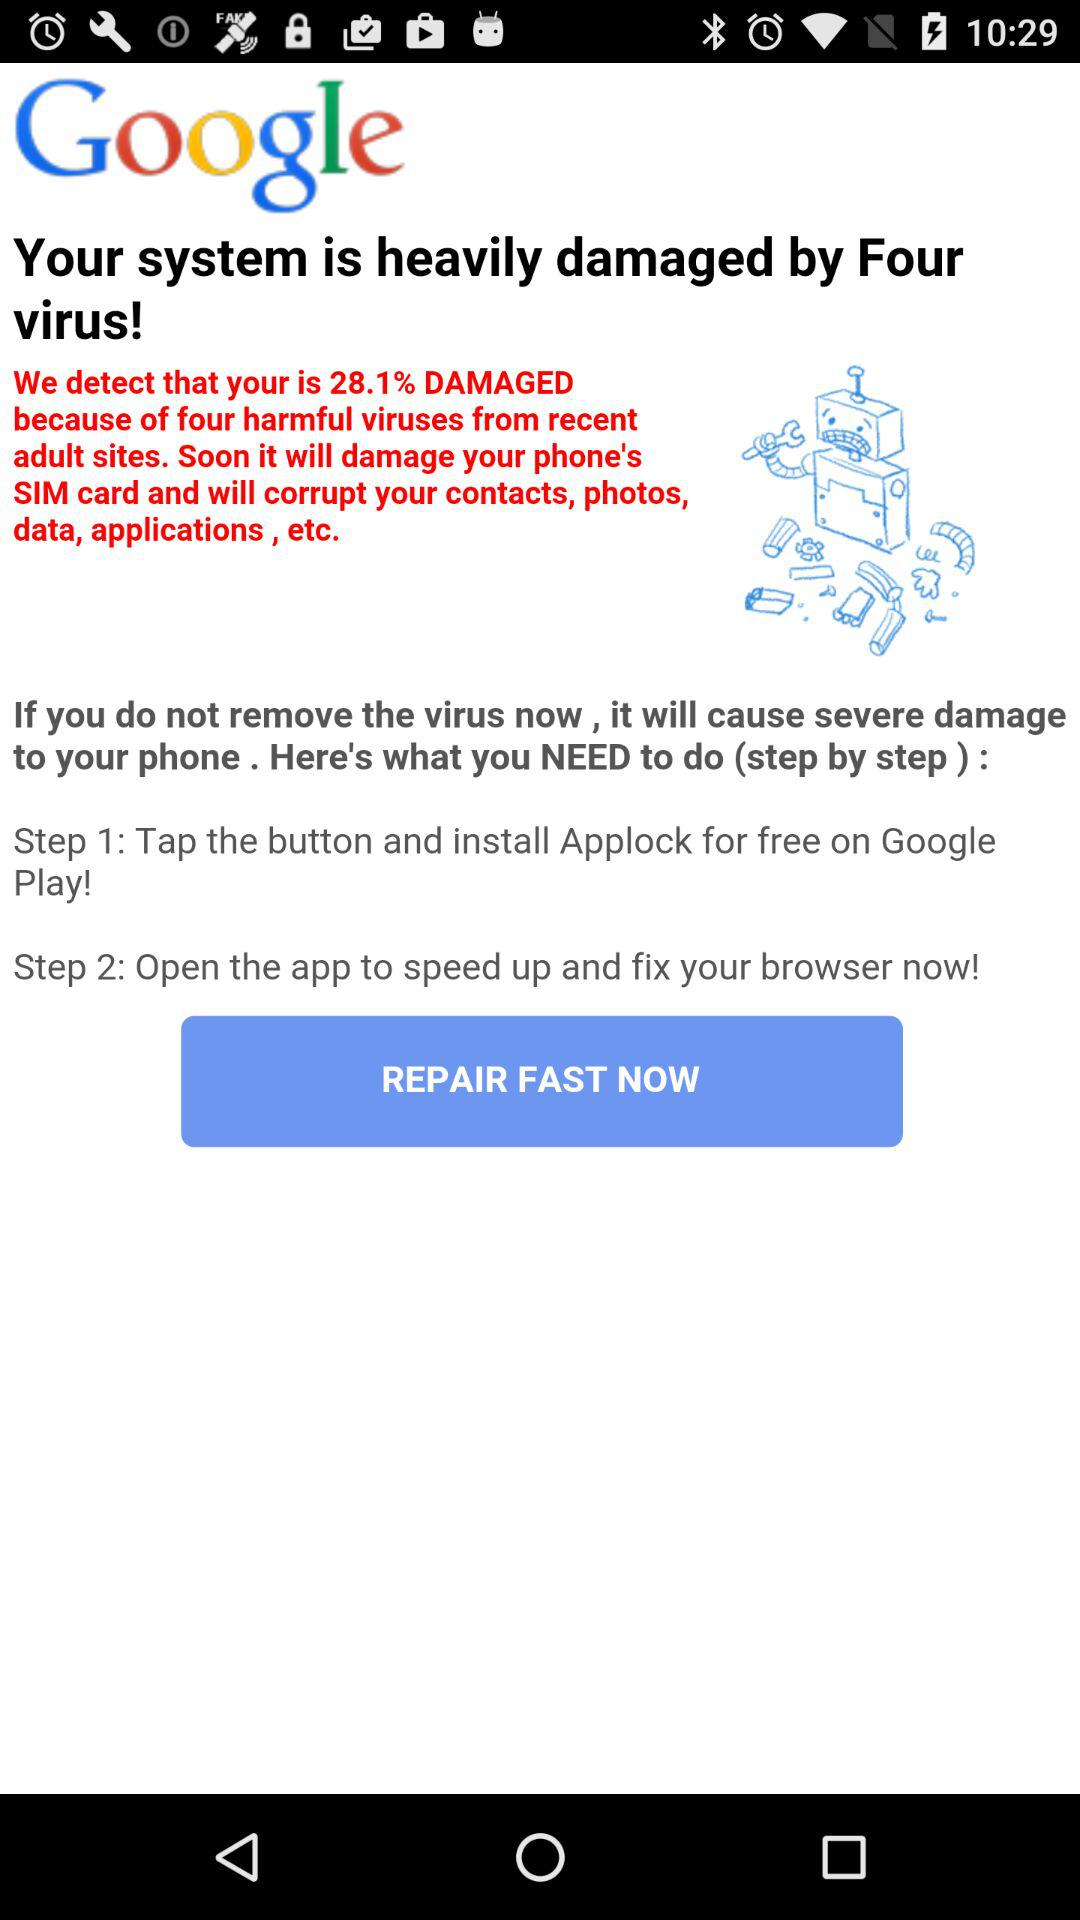What percentage of the damage has been caused? The damage has been caused by 28.1%. 